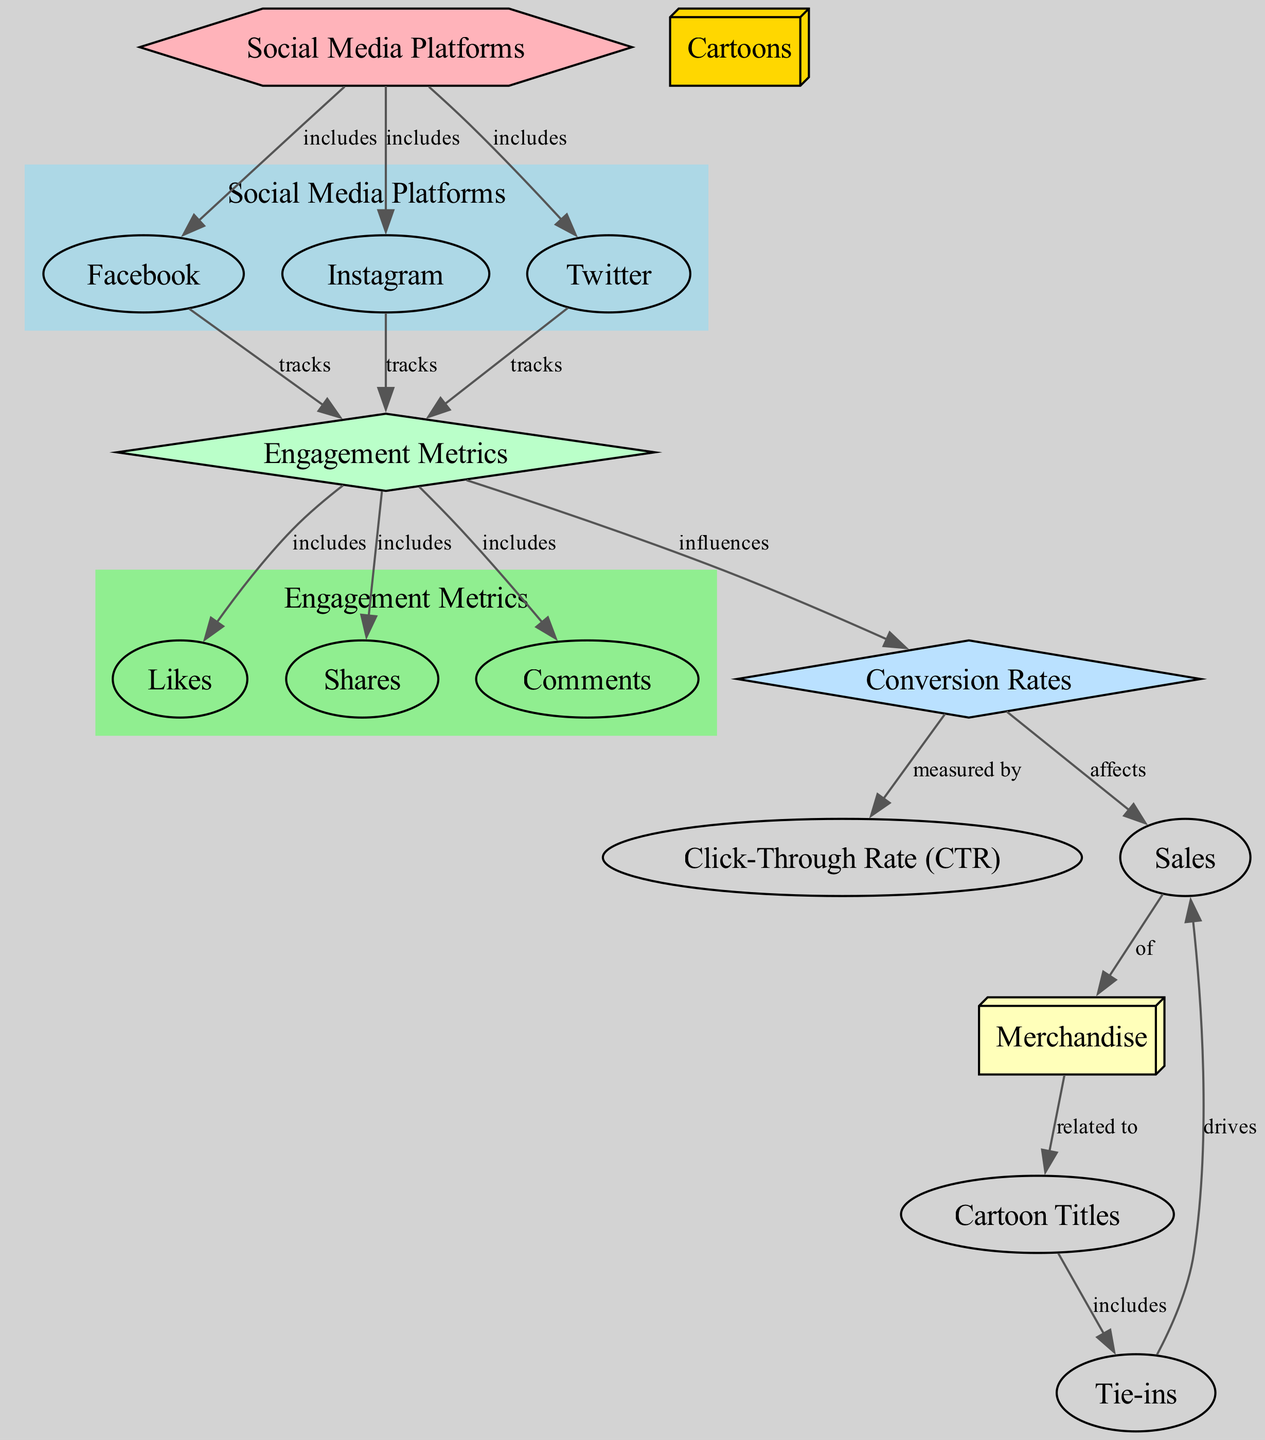What are the three social media platforms included in the diagram? The diagram specifies three social media platforms, namely Facebook, Instagram, and Twitter, each connected to the main node labeled "Social Media Platforms".
Answer: Facebook, Instagram, Twitter How many engagement metrics are tracked by the social media platforms? The engagement metrics tracked by the social media platforms include likes, shares, and comments. The diagram shows three direct connections from the "Engagement Metrics" node to these metrics.
Answer: 3 What is the relationship between conversion rates and sales? The diagram indicates that conversion rates affect sales, establishing a clear relationship where conversion rates influence how many sales are made through tie-in merchandise.
Answer: Affects What is the influence of engagement metrics on conversion rates? The diagram illustrates that engagement metrics influence conversion rates, indicating that higher engagement could lead to better conversion rates, which ultimately impacts sales.
Answer: Influences How do tie-ins drive sales according to the diagram? According to the diagram, tie-ins are directly linked to sales as they drive the sales of merchandise related to specific cartoon titles. This connection shows how tie-ins can result in increased revenue through related merchandise.
Answer: Drives 